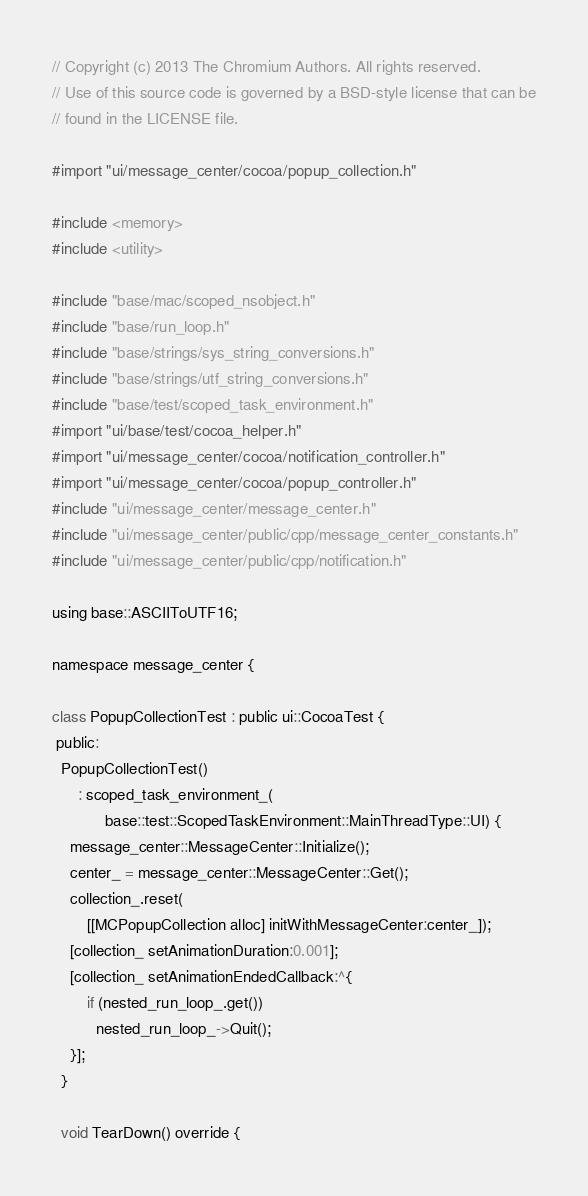<code> <loc_0><loc_0><loc_500><loc_500><_ObjectiveC_>// Copyright (c) 2013 The Chromium Authors. All rights reserved.
// Use of this source code is governed by a BSD-style license that can be
// found in the LICENSE file.

#import "ui/message_center/cocoa/popup_collection.h"

#include <memory>
#include <utility>

#include "base/mac/scoped_nsobject.h"
#include "base/run_loop.h"
#include "base/strings/sys_string_conversions.h"
#include "base/strings/utf_string_conversions.h"
#include "base/test/scoped_task_environment.h"
#import "ui/base/test/cocoa_helper.h"
#import "ui/message_center/cocoa/notification_controller.h"
#import "ui/message_center/cocoa/popup_controller.h"
#include "ui/message_center/message_center.h"
#include "ui/message_center/public/cpp/message_center_constants.h"
#include "ui/message_center/public/cpp/notification.h"

using base::ASCIIToUTF16;

namespace message_center {

class PopupCollectionTest : public ui::CocoaTest {
 public:
  PopupCollectionTest()
      : scoped_task_environment_(
            base::test::ScopedTaskEnvironment::MainThreadType::UI) {
    message_center::MessageCenter::Initialize();
    center_ = message_center::MessageCenter::Get();
    collection_.reset(
        [[MCPopupCollection alloc] initWithMessageCenter:center_]);
    [collection_ setAnimationDuration:0.001];
    [collection_ setAnimationEndedCallback:^{
        if (nested_run_loop_.get())
          nested_run_loop_->Quit();
    }];
  }

  void TearDown() override {</code> 